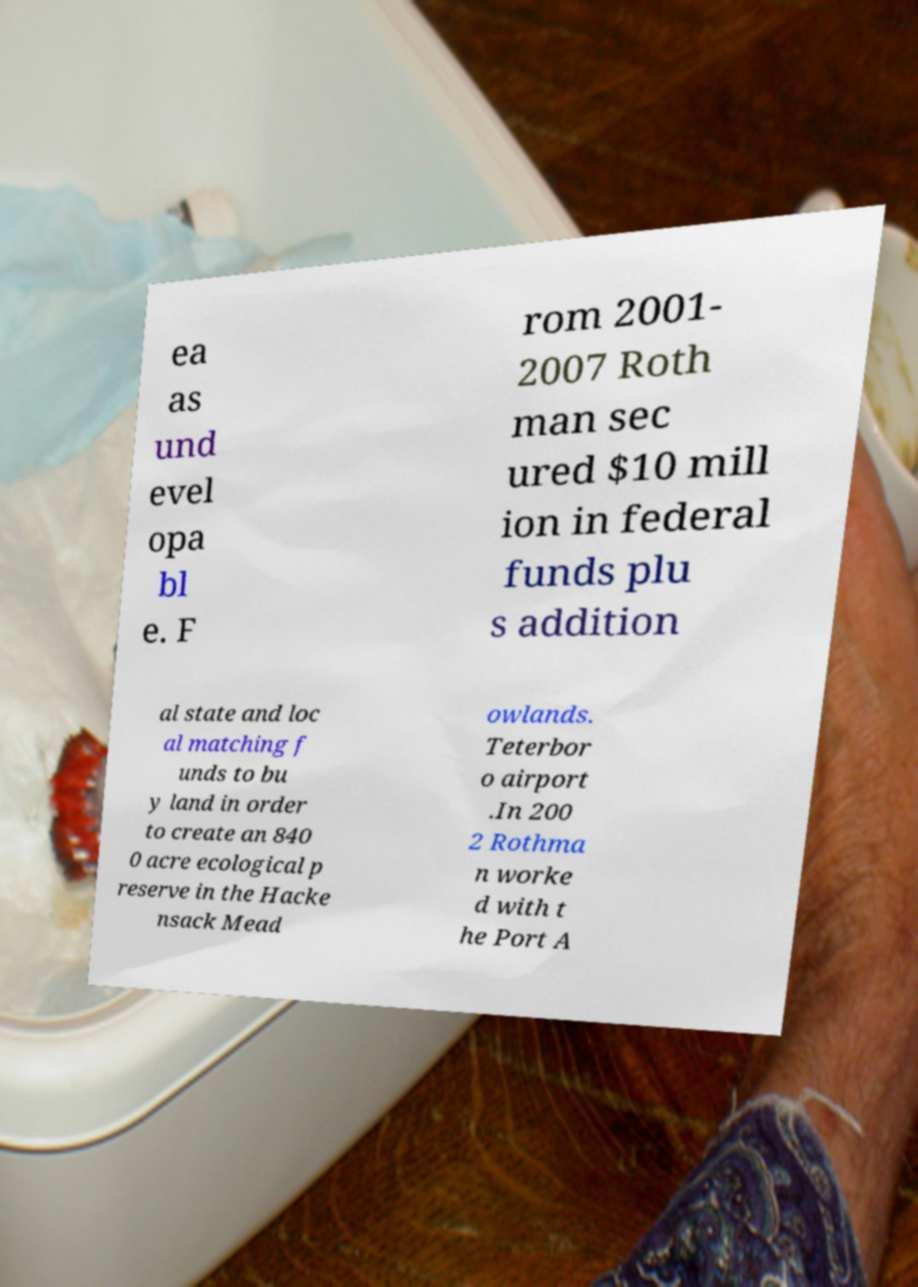Can you accurately transcribe the text from the provided image for me? ea as und evel opa bl e. F rom 2001- 2007 Roth man sec ured $10 mill ion in federal funds plu s addition al state and loc al matching f unds to bu y land in order to create an 840 0 acre ecological p reserve in the Hacke nsack Mead owlands. Teterbor o airport .In 200 2 Rothma n worke d with t he Port A 